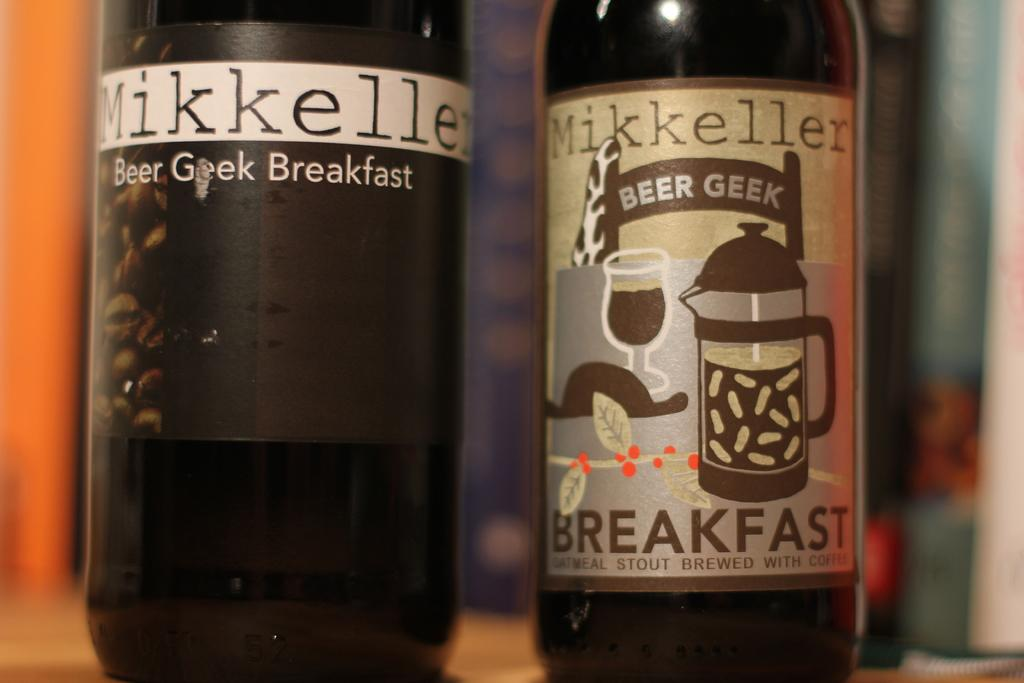<image>
Render a clear and concise summary of the photo. A few bottles of Mikkeller beer geek breakfast are shown. 